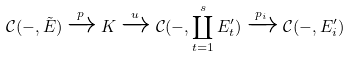<formula> <loc_0><loc_0><loc_500><loc_500>\mathcal { C } ( - , \tilde { E } ) \xrightarrow { p } K \xrightarrow { u } \mathcal { C } ( - , \coprod _ { t = 1 } ^ { s } E _ { t } ^ { \prime } ) \xrightarrow { p _ { i } } \mathcal { C } ( - , E _ { i } ^ { \prime } )</formula> 